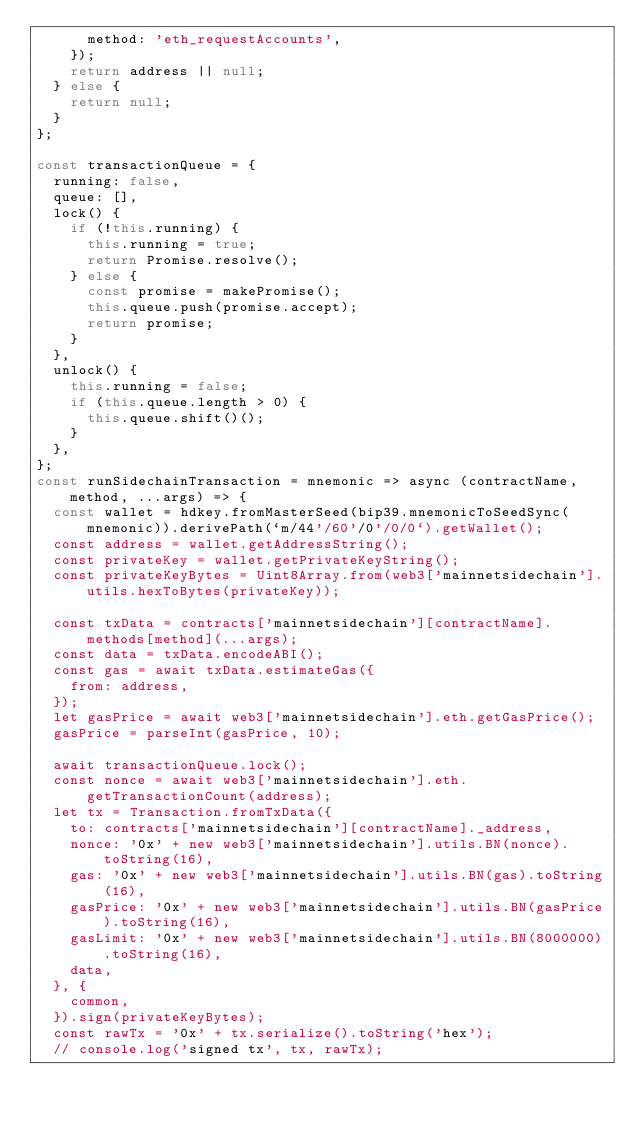<code> <loc_0><loc_0><loc_500><loc_500><_JavaScript_>      method: 'eth_requestAccounts',
    });
    return address || null;
  } else {
    return null;
  }
};

const transactionQueue = {
  running: false,
  queue: [],
  lock() {
    if (!this.running) {
      this.running = true;
      return Promise.resolve();
    } else {
      const promise = makePromise();
      this.queue.push(promise.accept);
      return promise;
    }
  },
  unlock() {
    this.running = false;
    if (this.queue.length > 0) {
      this.queue.shift()();
    }
  },
};
const runSidechainTransaction = mnemonic => async (contractName, method, ...args) => {
  const wallet = hdkey.fromMasterSeed(bip39.mnemonicToSeedSync(mnemonic)).derivePath(`m/44'/60'/0'/0/0`).getWallet();
  const address = wallet.getAddressString();
  const privateKey = wallet.getPrivateKeyString();
  const privateKeyBytes = Uint8Array.from(web3['mainnetsidechain'].utils.hexToBytes(privateKey));

  const txData = contracts['mainnetsidechain'][contractName].methods[method](...args);
  const data = txData.encodeABI();
  const gas = await txData.estimateGas({
    from: address,
  });
  let gasPrice = await web3['mainnetsidechain'].eth.getGasPrice();
  gasPrice = parseInt(gasPrice, 10);

  await transactionQueue.lock();
  const nonce = await web3['mainnetsidechain'].eth.getTransactionCount(address);
  let tx = Transaction.fromTxData({
    to: contracts['mainnetsidechain'][contractName]._address,
    nonce: '0x' + new web3['mainnetsidechain'].utils.BN(nonce).toString(16),
    gas: '0x' + new web3['mainnetsidechain'].utils.BN(gas).toString(16),
    gasPrice: '0x' + new web3['mainnetsidechain'].utils.BN(gasPrice).toString(16),
    gasLimit: '0x' + new web3['mainnetsidechain'].utils.BN(8000000).toString(16),
    data,
  }, {
    common,
  }).sign(privateKeyBytes);
  const rawTx = '0x' + tx.serialize().toString('hex');
  // console.log('signed tx', tx, rawTx);</code> 